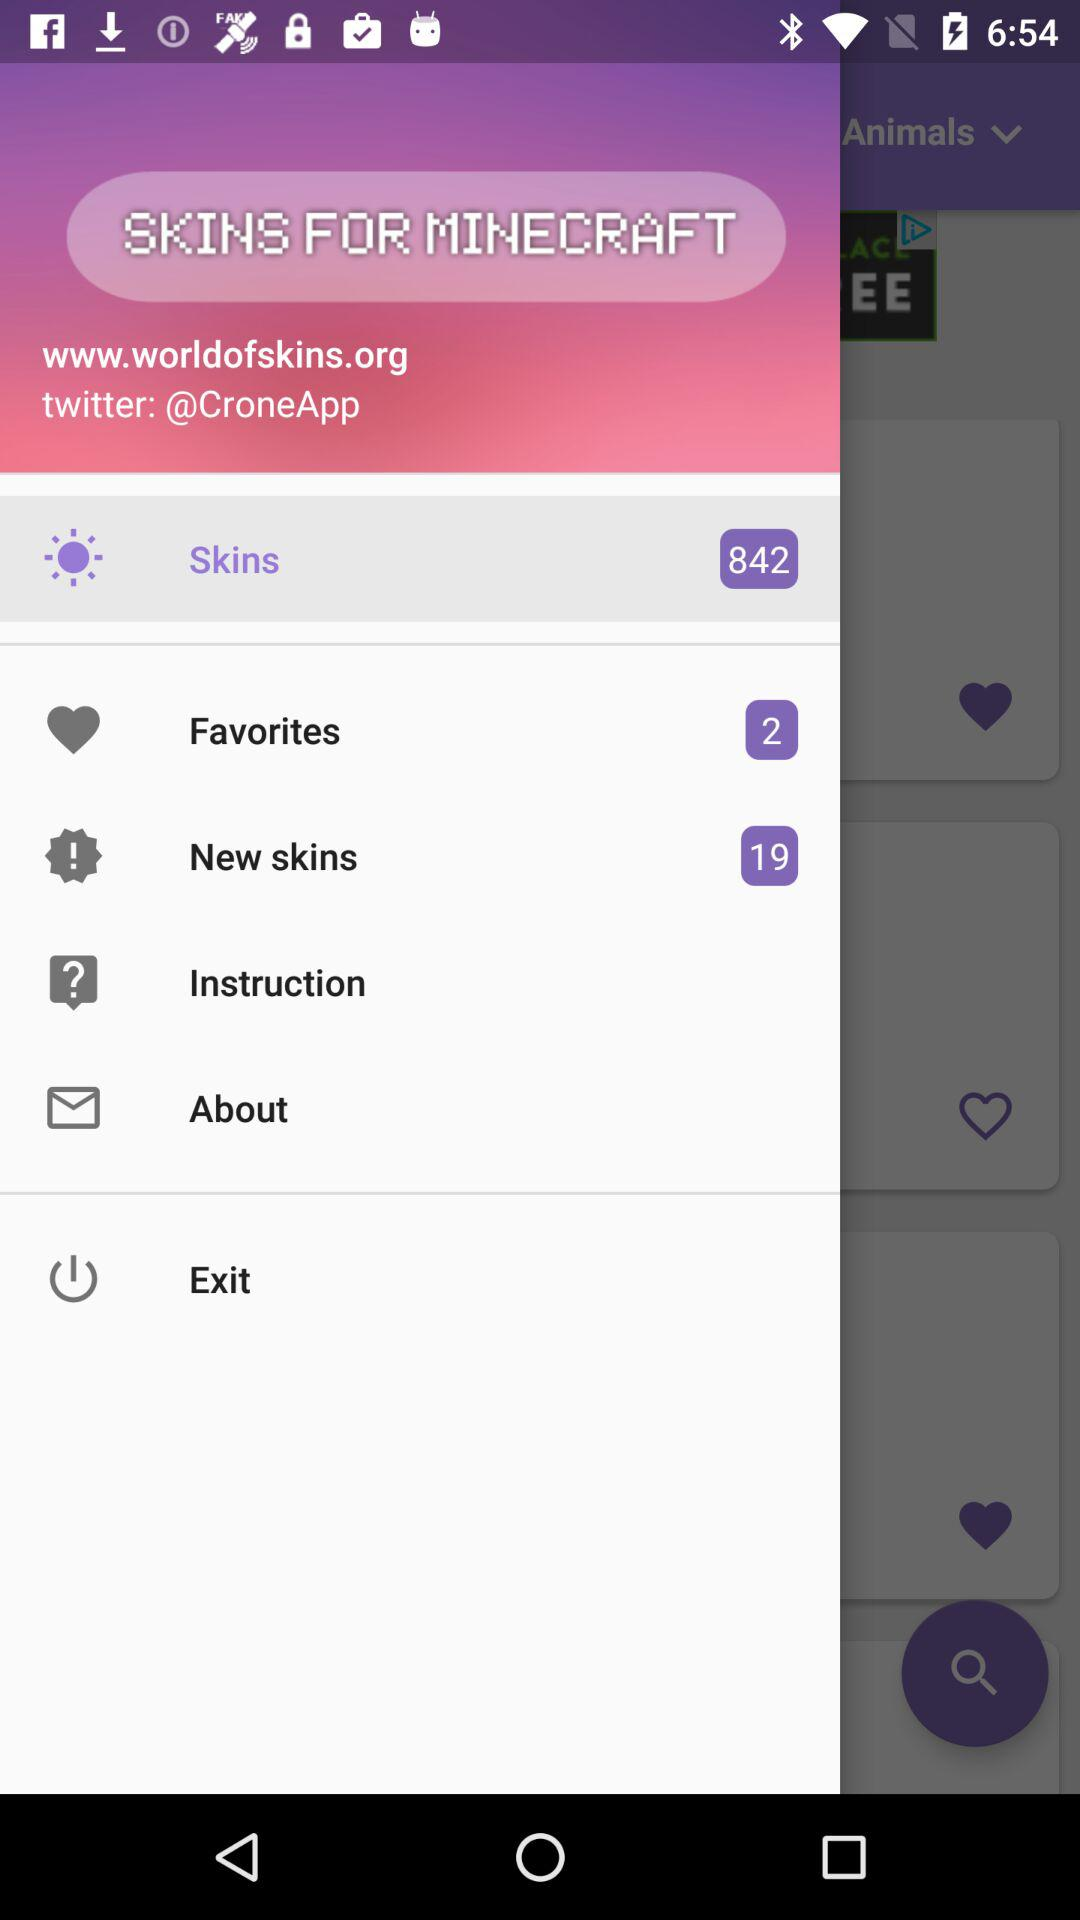What is the Twitter handle? The Twitter handle is "@CroneApp". 